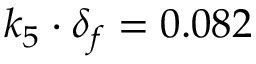<formula> <loc_0><loc_0><loc_500><loc_500>k _ { 5 } \cdot \delta _ { f } = 0 . 0 8 2</formula> 